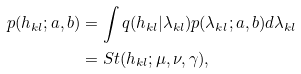<formula> <loc_0><loc_0><loc_500><loc_500>p ( h _ { k l } ; a , b ) & = \int q ( h _ { k l } | \lambda _ { k l } ) p ( \lambda _ { k l } ; a , b ) d \lambda _ { k l } \\ & = S t ( h _ { k l } ; \mu , \nu , \gamma ) ,</formula> 